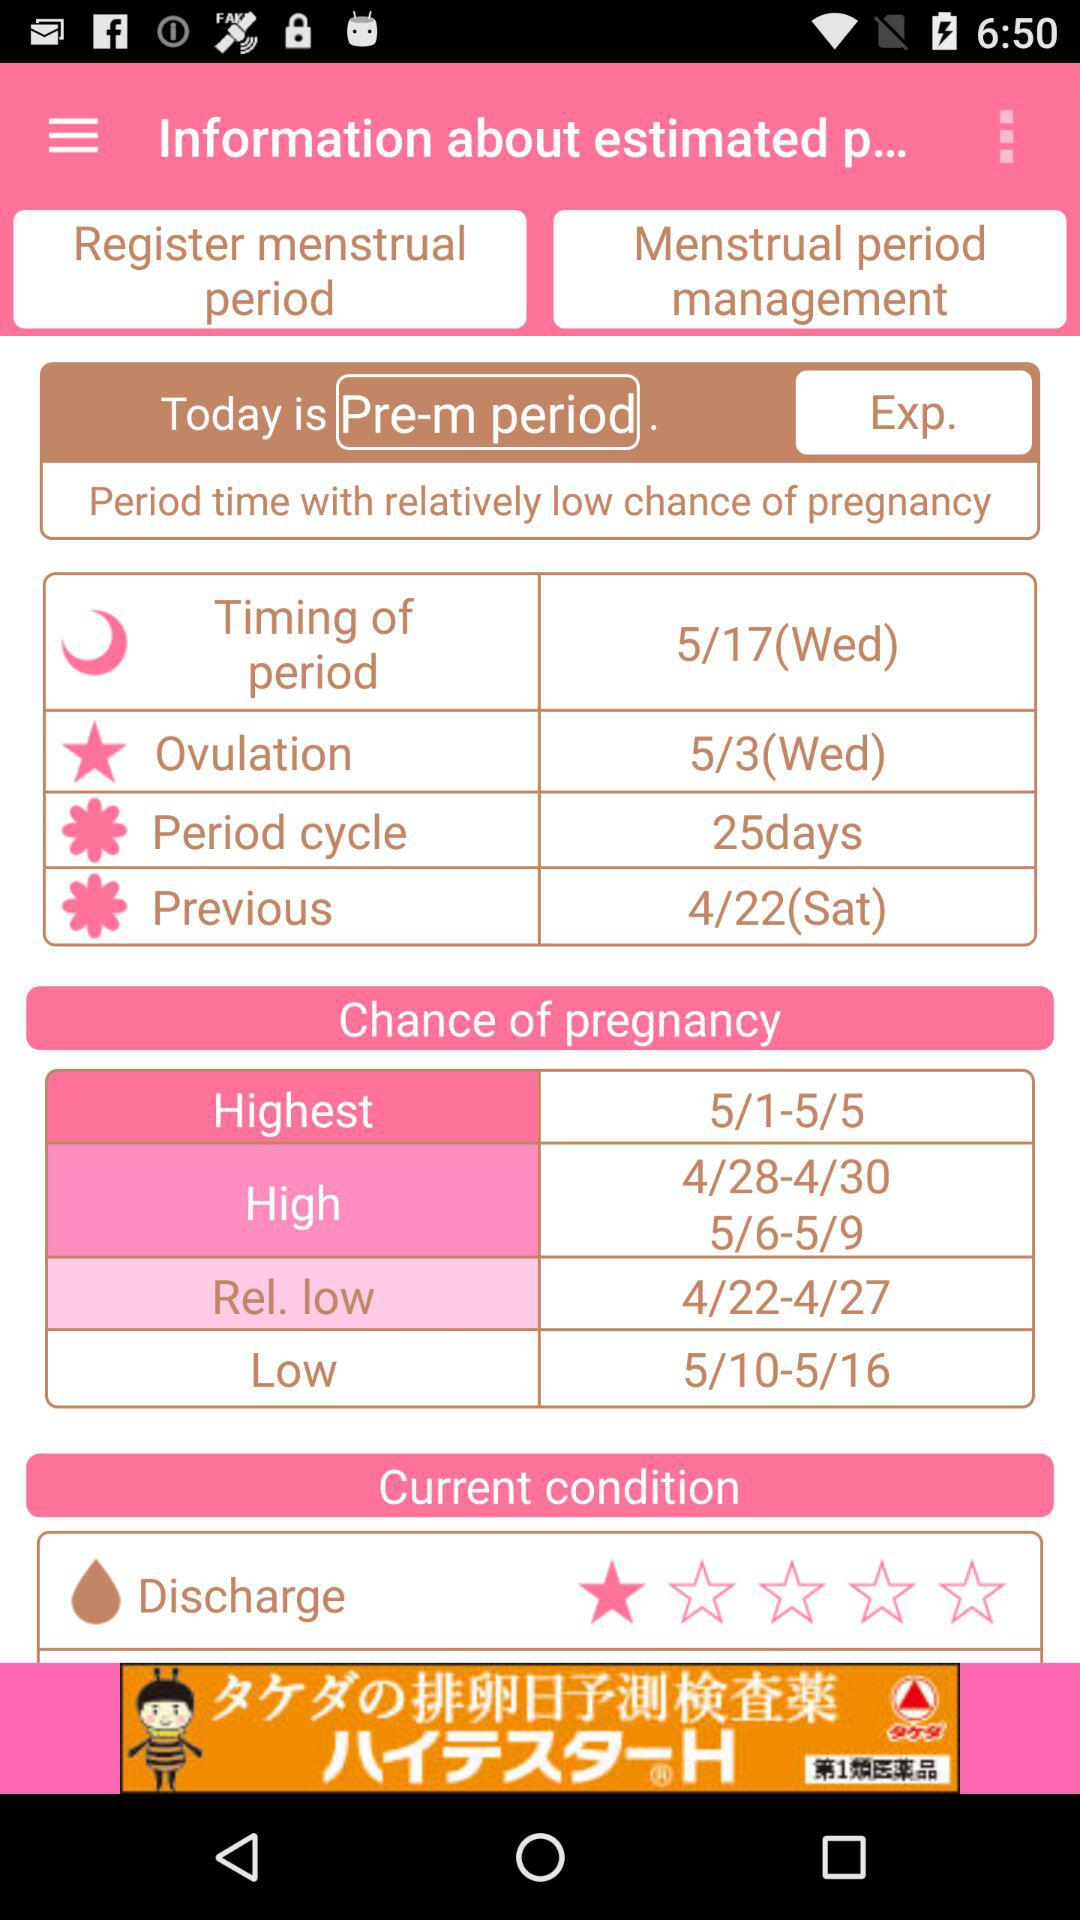How many days is the estimated length of the current menstrual cycle?
Answer the question using a single word or phrase. 25 days 